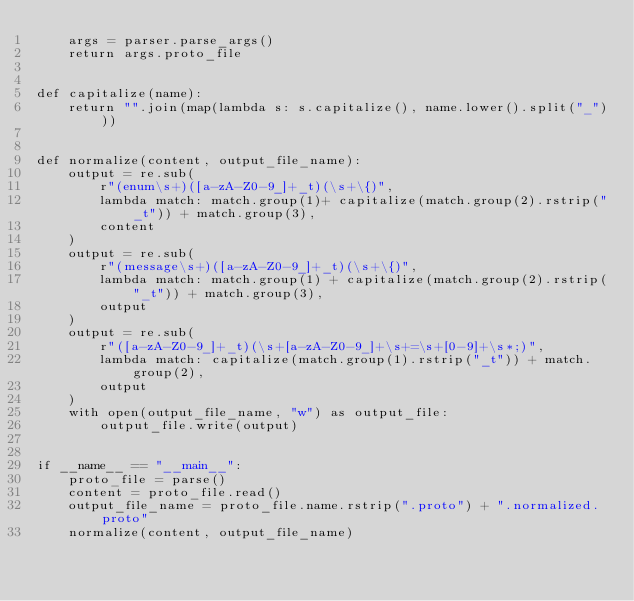Convert code to text. <code><loc_0><loc_0><loc_500><loc_500><_Python_>    args = parser.parse_args()
    return args.proto_file


def capitalize(name):
    return "".join(map(lambda s: s.capitalize(), name.lower().split("_")))


def normalize(content, output_file_name):
    output = re.sub(
        r"(enum\s+)([a-zA-Z0-9_]+_t)(\s+\{)",
        lambda match: match.group(1)+ capitalize(match.group(2).rstrip("_t")) + match.group(3), 
        content
    )
    output = re.sub(
        r"(message\s+)([a-zA-Z0-9_]+_t)(\s+\{)",
        lambda match: match.group(1) + capitalize(match.group(2).rstrip("_t")) + match.group(3),
        output
    )
    output = re.sub(
        r"([a-zA-Z0-9_]+_t)(\s+[a-zA-Z0-9_]+\s+=\s+[0-9]+\s*;)",
        lambda match: capitalize(match.group(1).rstrip("_t")) + match.group(2),
        output
    )
    with open(output_file_name, "w") as output_file:
        output_file.write(output)


if __name__ == "__main__":
    proto_file = parse()
    content = proto_file.read()
    output_file_name = proto_file.name.rstrip(".proto") + ".normalized.proto"
    normalize(content, output_file_name)</code> 